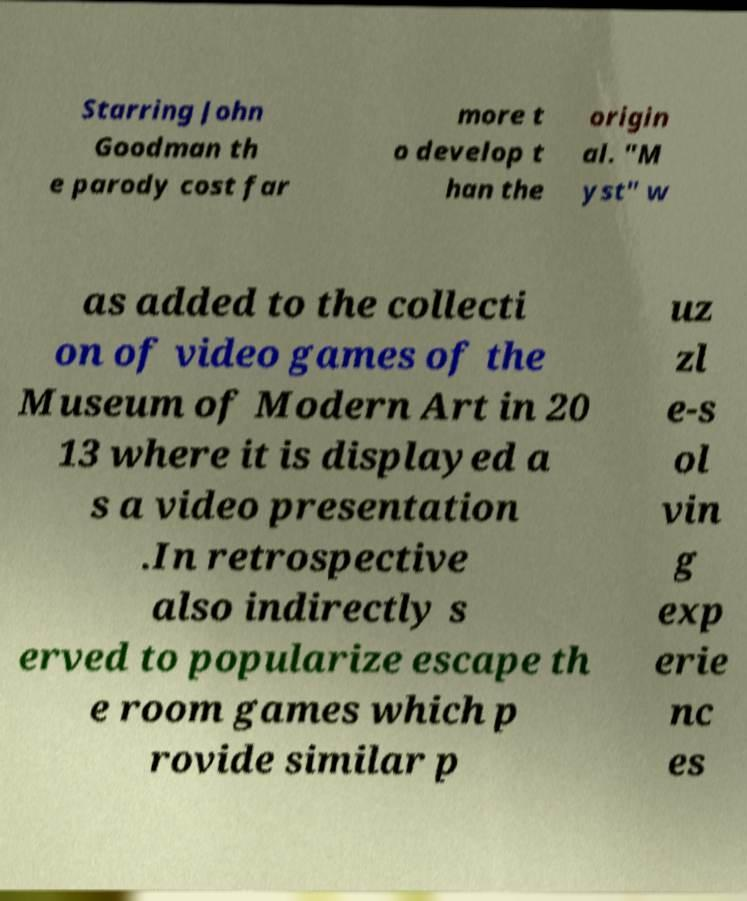What messages or text are displayed in this image? I need them in a readable, typed format. Starring John Goodman th e parody cost far more t o develop t han the origin al. "M yst" w as added to the collecti on of video games of the Museum of Modern Art in 20 13 where it is displayed a s a video presentation .In retrospective also indirectly s erved to popularize escape th e room games which p rovide similar p uz zl e-s ol vin g exp erie nc es 